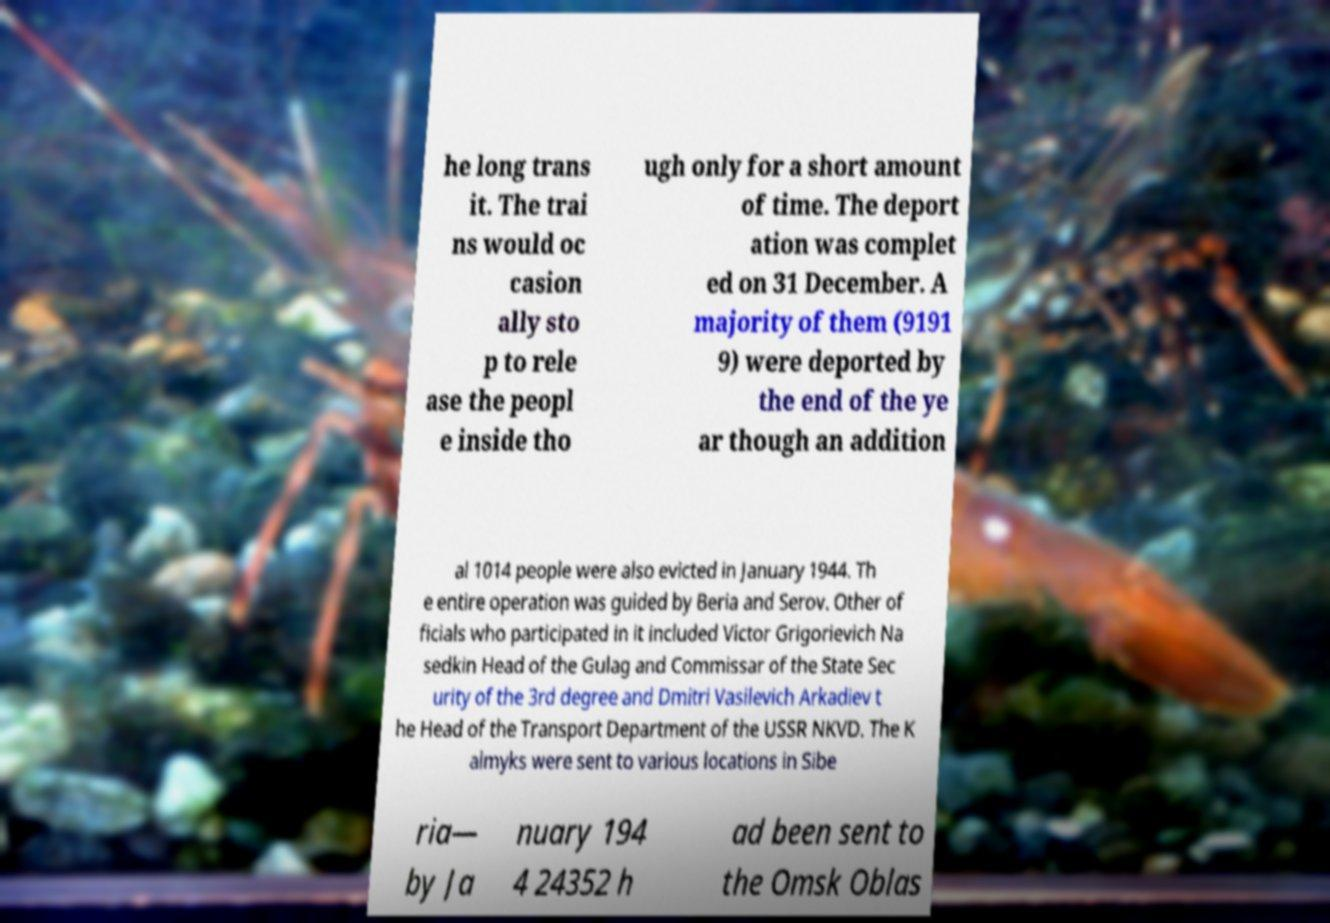What messages or text are displayed in this image? I need them in a readable, typed format. he long trans it. The trai ns would oc casion ally sto p to rele ase the peopl e inside tho ugh only for a short amount of time. The deport ation was complet ed on 31 December. A majority of them (9191 9) were deported by the end of the ye ar though an addition al 1014 people were also evicted in January 1944. Th e entire operation was guided by Beria and Serov. Other of ficials who participated in it included Victor Grigorievich Na sedkin Head of the Gulag and Commissar of the State Sec urity of the 3rd degree and Dmitri Vasilevich Arkadiev t he Head of the Transport Department of the USSR NKVD. The K almyks were sent to various locations in Sibe ria— by Ja nuary 194 4 24352 h ad been sent to the Omsk Oblas 